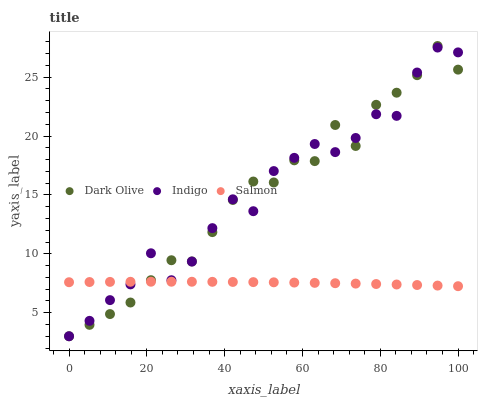Does Salmon have the minimum area under the curve?
Answer yes or no. Yes. Does Indigo have the maximum area under the curve?
Answer yes or no. Yes. Does Dark Olive have the minimum area under the curve?
Answer yes or no. No. Does Dark Olive have the maximum area under the curve?
Answer yes or no. No. Is Salmon the smoothest?
Answer yes or no. Yes. Is Indigo the roughest?
Answer yes or no. Yes. Is Dark Olive the smoothest?
Answer yes or no. No. Is Dark Olive the roughest?
Answer yes or no. No. Does Dark Olive have the lowest value?
Answer yes or no. Yes. Does Dark Olive have the highest value?
Answer yes or no. Yes. Does Indigo have the highest value?
Answer yes or no. No. Does Dark Olive intersect Indigo?
Answer yes or no. Yes. Is Dark Olive less than Indigo?
Answer yes or no. No. Is Dark Olive greater than Indigo?
Answer yes or no. No. 